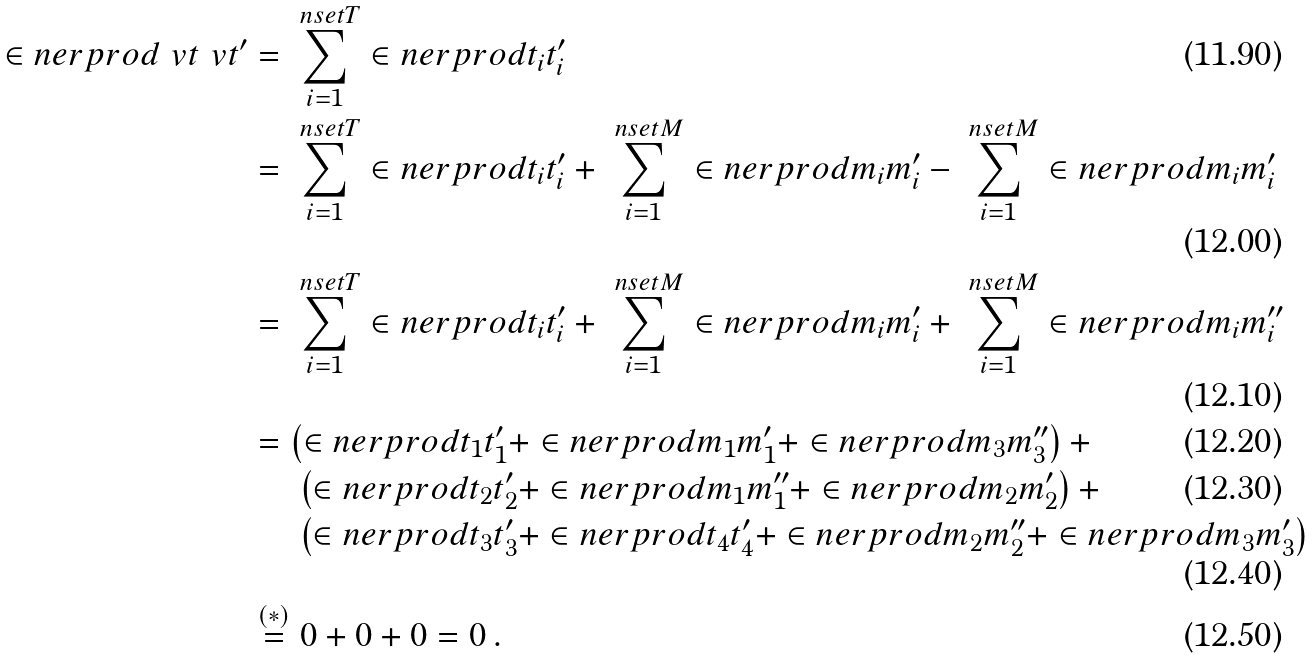Convert formula to latex. <formula><loc_0><loc_0><loc_500><loc_500>\in n e r p r o d { \ v t } { \ v t ^ { \prime } } & = \sum _ { i = 1 } ^ { \ n s e t { T } } \in n e r p r o d { t _ { i } } { t ^ { \prime } _ { i } } \\ & = \sum _ { i = 1 } ^ { \ n s e t { T } } \in n e r p r o d { t _ { i } } { t ^ { \prime } _ { i } } + \sum _ { i = 1 } ^ { \ n s e t { M } } \in n e r p r o d { m _ { i } } { m ^ { \prime } _ { i } } - \sum _ { i = 1 } ^ { \ n s e t { M } } \in n e r p r o d { m _ { i } } { m ^ { \prime } _ { i } } \\ & = \sum _ { i = 1 } ^ { \ n s e t { T } } \in n e r p r o d { t _ { i } } { t ^ { \prime } _ { i } } + \sum _ { i = 1 } ^ { \ n s e t { M } } \in n e r p r o d { m _ { i } } { m ^ { \prime } _ { i } } + \sum _ { i = 1 } ^ { \ n s e t { M } } \in n e r p r o d { m _ { i } } { m ^ { \prime \prime } _ { i } } \\ & = \left ( \in n e r p r o d { t _ { 1 } } { t ^ { \prime } _ { 1 } } + \in n e r p r o d { m _ { 1 } } { m ^ { \prime } _ { 1 } } + \in n e r p r o d { m _ { 3 } } { m ^ { \prime \prime } _ { 3 } } \right ) + \\ & \quad \ \left ( \in n e r p r o d { t _ { 2 } } { t ^ { \prime } _ { 2 } } + \in n e r p r o d { m _ { 1 } } { m ^ { \prime \prime } _ { 1 } } + \in n e r p r o d { m _ { 2 } } { m ^ { \prime } _ { 2 } } \right ) + \\ & \quad \ \left ( \in n e r p r o d { t _ { 3 } } { t ^ { \prime } _ { 3 } } + \in n e r p r o d { t _ { 4 } } { t ^ { \prime } _ { 4 } } + \in n e r p r o d { m _ { 2 } } { m ^ { \prime \prime } _ { 2 } } + \in n e r p r o d { m _ { 3 } } { m ^ { \prime } _ { 3 } } \right ) \\ & \overset { ( * ) } { = } 0 + 0 + 0 = 0 \, .</formula> 